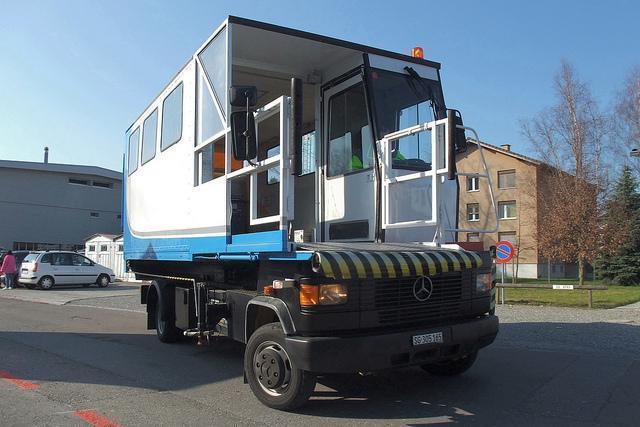What company made this vehicle?
Choose the right answer from the provided options to respond to the question.
Options: Mercedes, toyota, audi, hyundai. Mercedes. 